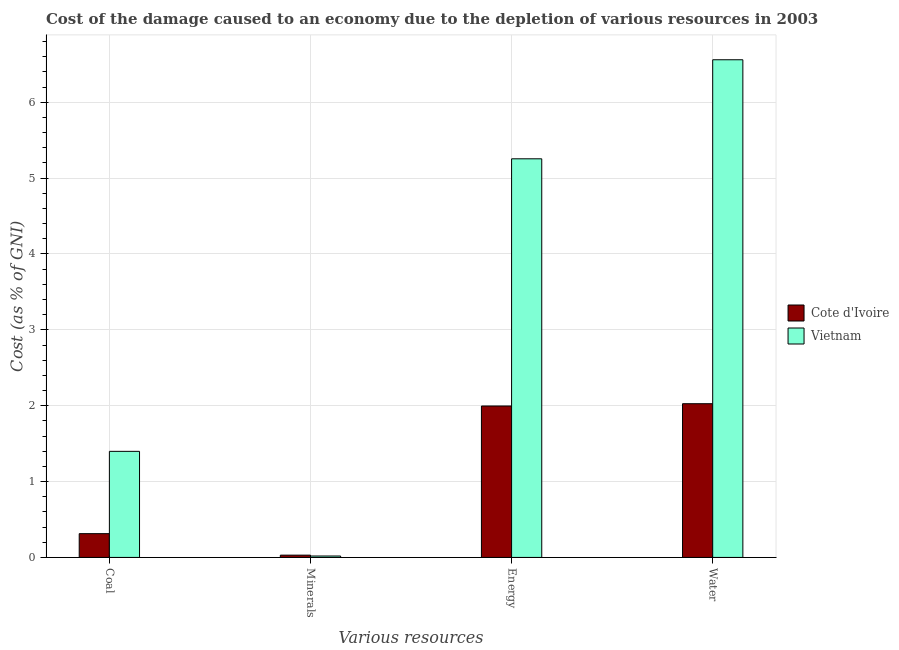How many different coloured bars are there?
Keep it short and to the point. 2. How many groups of bars are there?
Offer a very short reply. 4. Are the number of bars per tick equal to the number of legend labels?
Your answer should be very brief. Yes. What is the label of the 2nd group of bars from the left?
Offer a very short reply. Minerals. What is the cost of damage due to depletion of minerals in Cote d'Ivoire?
Provide a short and direct response. 0.03. Across all countries, what is the maximum cost of damage due to depletion of water?
Give a very brief answer. 6.56. Across all countries, what is the minimum cost of damage due to depletion of energy?
Offer a very short reply. 2. In which country was the cost of damage due to depletion of energy maximum?
Your response must be concise. Vietnam. In which country was the cost of damage due to depletion of minerals minimum?
Provide a short and direct response. Vietnam. What is the total cost of damage due to depletion of energy in the graph?
Offer a terse response. 7.25. What is the difference between the cost of damage due to depletion of coal in Vietnam and that in Cote d'Ivoire?
Make the answer very short. 1.08. What is the difference between the cost of damage due to depletion of coal in Vietnam and the cost of damage due to depletion of minerals in Cote d'Ivoire?
Keep it short and to the point. 1.37. What is the average cost of damage due to depletion of minerals per country?
Keep it short and to the point. 0.02. What is the difference between the cost of damage due to depletion of coal and cost of damage due to depletion of water in Vietnam?
Offer a very short reply. -5.16. What is the ratio of the cost of damage due to depletion of energy in Cote d'Ivoire to that in Vietnam?
Provide a succinct answer. 0.38. What is the difference between the highest and the second highest cost of damage due to depletion of energy?
Your answer should be very brief. 3.26. What is the difference between the highest and the lowest cost of damage due to depletion of minerals?
Your answer should be compact. 0.01. In how many countries, is the cost of damage due to depletion of minerals greater than the average cost of damage due to depletion of minerals taken over all countries?
Give a very brief answer. 1. Is the sum of the cost of damage due to depletion of minerals in Vietnam and Cote d'Ivoire greater than the maximum cost of damage due to depletion of coal across all countries?
Your answer should be very brief. No. What does the 2nd bar from the left in Coal represents?
Provide a succinct answer. Vietnam. What does the 1st bar from the right in Coal represents?
Provide a succinct answer. Vietnam. Are all the bars in the graph horizontal?
Your answer should be very brief. No. How many countries are there in the graph?
Offer a very short reply. 2. Are the values on the major ticks of Y-axis written in scientific E-notation?
Give a very brief answer. No. Does the graph contain any zero values?
Your answer should be very brief. No. Does the graph contain grids?
Offer a very short reply. Yes. How many legend labels are there?
Your answer should be compact. 2. How are the legend labels stacked?
Keep it short and to the point. Vertical. What is the title of the graph?
Offer a very short reply. Cost of the damage caused to an economy due to the depletion of various resources in 2003 . What is the label or title of the X-axis?
Your answer should be very brief. Various resources. What is the label or title of the Y-axis?
Your answer should be compact. Cost (as % of GNI). What is the Cost (as % of GNI) in Cote d'Ivoire in Coal?
Provide a succinct answer. 0.31. What is the Cost (as % of GNI) of Vietnam in Coal?
Your answer should be very brief. 1.4. What is the Cost (as % of GNI) of Cote d'Ivoire in Minerals?
Your answer should be compact. 0.03. What is the Cost (as % of GNI) of Vietnam in Minerals?
Provide a short and direct response. 0.02. What is the Cost (as % of GNI) of Cote d'Ivoire in Energy?
Offer a terse response. 2. What is the Cost (as % of GNI) in Vietnam in Energy?
Your response must be concise. 5.25. What is the Cost (as % of GNI) in Cote d'Ivoire in Water?
Ensure brevity in your answer.  2.03. What is the Cost (as % of GNI) of Vietnam in Water?
Your answer should be very brief. 6.56. Across all Various resources, what is the maximum Cost (as % of GNI) of Cote d'Ivoire?
Make the answer very short. 2.03. Across all Various resources, what is the maximum Cost (as % of GNI) of Vietnam?
Make the answer very short. 6.56. Across all Various resources, what is the minimum Cost (as % of GNI) in Cote d'Ivoire?
Give a very brief answer. 0.03. Across all Various resources, what is the minimum Cost (as % of GNI) in Vietnam?
Offer a very short reply. 0.02. What is the total Cost (as % of GNI) of Cote d'Ivoire in the graph?
Provide a succinct answer. 4.37. What is the total Cost (as % of GNI) of Vietnam in the graph?
Offer a very short reply. 13.23. What is the difference between the Cost (as % of GNI) of Cote d'Ivoire in Coal and that in Minerals?
Give a very brief answer. 0.28. What is the difference between the Cost (as % of GNI) in Vietnam in Coal and that in Minerals?
Offer a very short reply. 1.38. What is the difference between the Cost (as % of GNI) of Cote d'Ivoire in Coal and that in Energy?
Your answer should be compact. -1.68. What is the difference between the Cost (as % of GNI) of Vietnam in Coal and that in Energy?
Offer a terse response. -3.86. What is the difference between the Cost (as % of GNI) of Cote d'Ivoire in Coal and that in Water?
Your response must be concise. -1.71. What is the difference between the Cost (as % of GNI) of Vietnam in Coal and that in Water?
Offer a very short reply. -5.16. What is the difference between the Cost (as % of GNI) of Cote d'Ivoire in Minerals and that in Energy?
Provide a succinct answer. -1.97. What is the difference between the Cost (as % of GNI) of Vietnam in Minerals and that in Energy?
Provide a succinct answer. -5.24. What is the difference between the Cost (as % of GNI) in Cote d'Ivoire in Minerals and that in Water?
Make the answer very short. -2. What is the difference between the Cost (as % of GNI) in Vietnam in Minerals and that in Water?
Offer a very short reply. -6.54. What is the difference between the Cost (as % of GNI) in Cote d'Ivoire in Energy and that in Water?
Offer a terse response. -0.03. What is the difference between the Cost (as % of GNI) in Vietnam in Energy and that in Water?
Provide a succinct answer. -1.31. What is the difference between the Cost (as % of GNI) of Cote d'Ivoire in Coal and the Cost (as % of GNI) of Vietnam in Minerals?
Keep it short and to the point. 0.29. What is the difference between the Cost (as % of GNI) of Cote d'Ivoire in Coal and the Cost (as % of GNI) of Vietnam in Energy?
Offer a terse response. -4.94. What is the difference between the Cost (as % of GNI) of Cote d'Ivoire in Coal and the Cost (as % of GNI) of Vietnam in Water?
Provide a short and direct response. -6.25. What is the difference between the Cost (as % of GNI) in Cote d'Ivoire in Minerals and the Cost (as % of GNI) in Vietnam in Energy?
Your answer should be compact. -5.22. What is the difference between the Cost (as % of GNI) in Cote d'Ivoire in Minerals and the Cost (as % of GNI) in Vietnam in Water?
Offer a very short reply. -6.53. What is the difference between the Cost (as % of GNI) in Cote d'Ivoire in Energy and the Cost (as % of GNI) in Vietnam in Water?
Offer a very short reply. -4.56. What is the average Cost (as % of GNI) in Cote d'Ivoire per Various resources?
Your answer should be compact. 1.09. What is the average Cost (as % of GNI) of Vietnam per Various resources?
Offer a terse response. 3.31. What is the difference between the Cost (as % of GNI) in Cote d'Ivoire and Cost (as % of GNI) in Vietnam in Coal?
Your response must be concise. -1.08. What is the difference between the Cost (as % of GNI) in Cote d'Ivoire and Cost (as % of GNI) in Vietnam in Minerals?
Your answer should be very brief. 0.01. What is the difference between the Cost (as % of GNI) in Cote d'Ivoire and Cost (as % of GNI) in Vietnam in Energy?
Provide a succinct answer. -3.26. What is the difference between the Cost (as % of GNI) of Cote d'Ivoire and Cost (as % of GNI) of Vietnam in Water?
Offer a terse response. -4.53. What is the ratio of the Cost (as % of GNI) in Cote d'Ivoire in Coal to that in Minerals?
Ensure brevity in your answer.  10.41. What is the ratio of the Cost (as % of GNI) in Vietnam in Coal to that in Minerals?
Offer a very short reply. 74.69. What is the ratio of the Cost (as % of GNI) in Cote d'Ivoire in Coal to that in Energy?
Offer a very short reply. 0.16. What is the ratio of the Cost (as % of GNI) of Vietnam in Coal to that in Energy?
Provide a short and direct response. 0.27. What is the ratio of the Cost (as % of GNI) of Cote d'Ivoire in Coal to that in Water?
Keep it short and to the point. 0.15. What is the ratio of the Cost (as % of GNI) in Vietnam in Coal to that in Water?
Keep it short and to the point. 0.21. What is the ratio of the Cost (as % of GNI) in Cote d'Ivoire in Minerals to that in Energy?
Provide a succinct answer. 0.02. What is the ratio of the Cost (as % of GNI) in Vietnam in Minerals to that in Energy?
Make the answer very short. 0. What is the ratio of the Cost (as % of GNI) in Cote d'Ivoire in Minerals to that in Water?
Make the answer very short. 0.01. What is the ratio of the Cost (as % of GNI) of Vietnam in Minerals to that in Water?
Give a very brief answer. 0. What is the ratio of the Cost (as % of GNI) in Cote d'Ivoire in Energy to that in Water?
Your answer should be compact. 0.99. What is the ratio of the Cost (as % of GNI) in Vietnam in Energy to that in Water?
Provide a short and direct response. 0.8. What is the difference between the highest and the second highest Cost (as % of GNI) in Cote d'Ivoire?
Provide a short and direct response. 0.03. What is the difference between the highest and the second highest Cost (as % of GNI) in Vietnam?
Your answer should be very brief. 1.31. What is the difference between the highest and the lowest Cost (as % of GNI) of Cote d'Ivoire?
Make the answer very short. 2. What is the difference between the highest and the lowest Cost (as % of GNI) of Vietnam?
Ensure brevity in your answer.  6.54. 